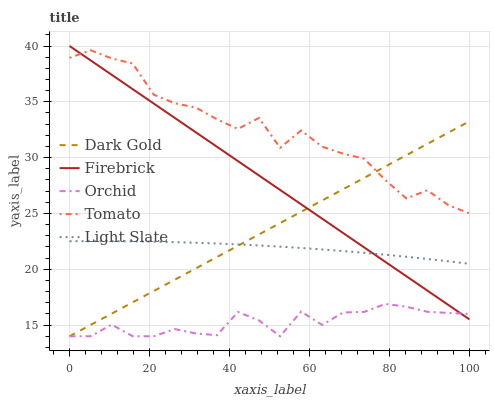Does Orchid have the minimum area under the curve?
Answer yes or no. Yes. Does Tomato have the maximum area under the curve?
Answer yes or no. Yes. Does Light Slate have the minimum area under the curve?
Answer yes or no. No. Does Light Slate have the maximum area under the curve?
Answer yes or no. No. Is Dark Gold the smoothest?
Answer yes or no. Yes. Is Tomato the roughest?
Answer yes or no. Yes. Is Light Slate the smoothest?
Answer yes or no. No. Is Light Slate the roughest?
Answer yes or no. No. Does Orchid have the lowest value?
Answer yes or no. Yes. Does Light Slate have the lowest value?
Answer yes or no. No. Does Firebrick have the highest value?
Answer yes or no. Yes. Does Light Slate have the highest value?
Answer yes or no. No. Is Orchid less than Tomato?
Answer yes or no. Yes. Is Tomato greater than Light Slate?
Answer yes or no. Yes. Does Light Slate intersect Dark Gold?
Answer yes or no. Yes. Is Light Slate less than Dark Gold?
Answer yes or no. No. Is Light Slate greater than Dark Gold?
Answer yes or no. No. Does Orchid intersect Tomato?
Answer yes or no. No. 